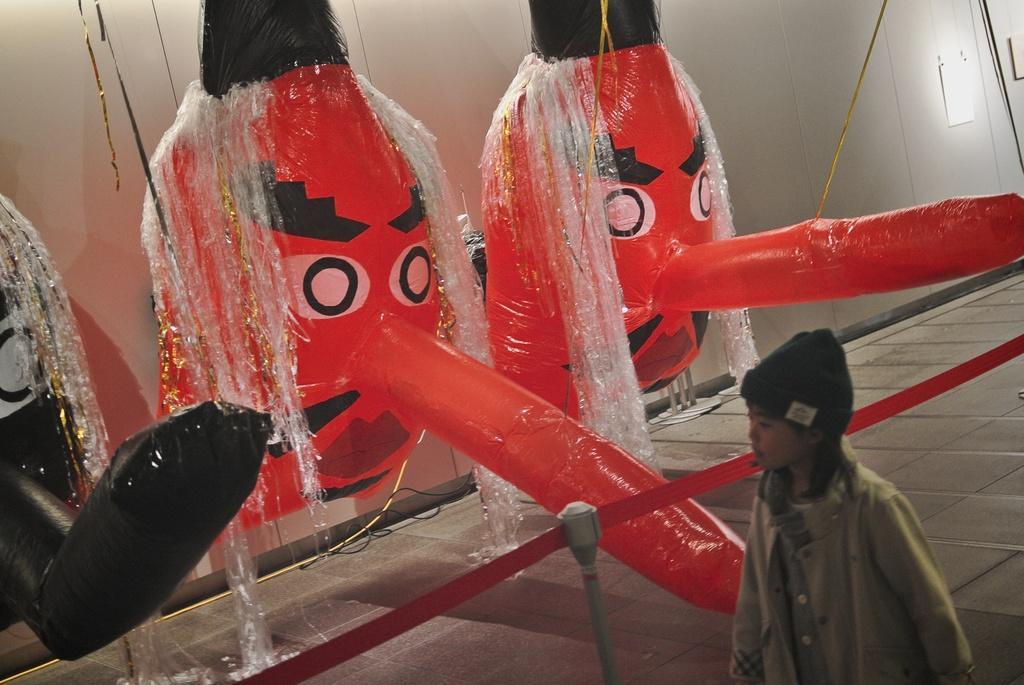Could you give a brief overview of what you see in this image? At the bottom of the picture, we see the girl is standing. She is wearing a cap. Beside her, we see the barrier pole. In the background, we see a wall and the inflated balloons in red and black color. At the bottom, we see the floor. 